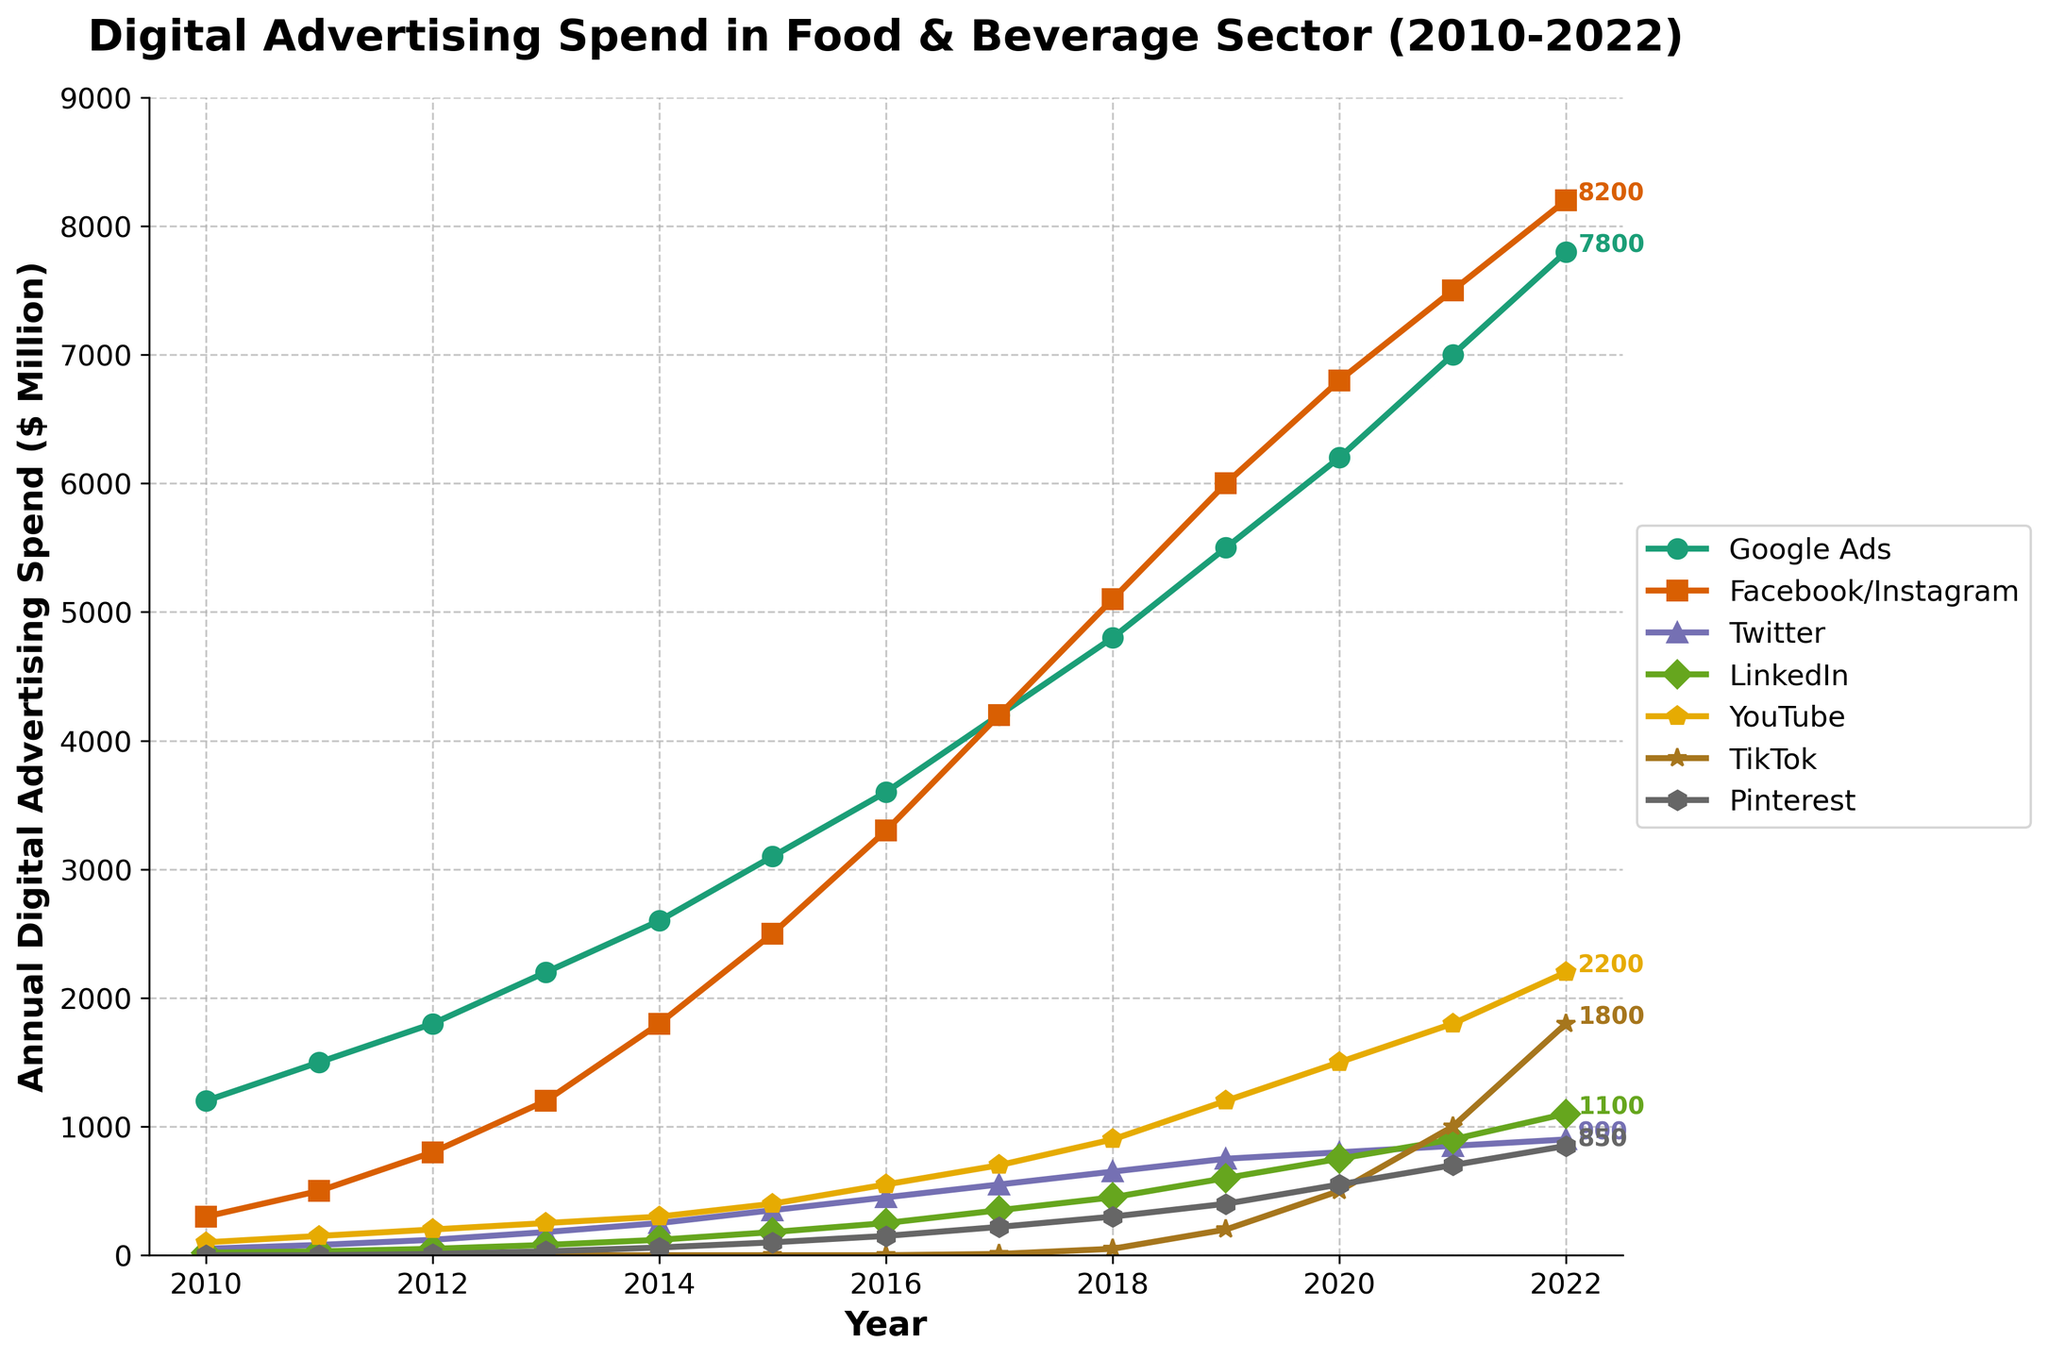what's the overall trend in Google Ads spending from 2010 to 2022? By observing the line representing Google Ads, we can see a steady increase in the annual advertising spend over the years. The line moves upwards from approximately $1200M in 2010 to around $7800M in 2022, indicating a consistent rise.
Answer: Increasing trend Which platform saw the largest growth in advertising spend between 2017 and 2022? To determine the largest growth, we need to compare the increase in spend for each platform between 2017 and 2022. By subtracting the 2017 values from the 2022 values, YouTube had the highest increase from $700M to $2200M, which is an increase of $1500M.
Answer: YouTube What's the difference in advertising spend between Google Ads and Facebook/Instagram in 2022? For 2022, the advertising spend for Google Ads is $7800M and for Facebook/Instagram is $8200M. The difference is calculated by subtracting Google Ads spend from Facebook/Instagram spend: $8200M - $7800M = $400M.
Answer: $400M Which platform had the smallest advertising spend in 2010? By looking at the values for all platforms in 2010, Twitter had the smallest spend with $50M, followed closely by LinkedIn with $20M.
Answer: LinkedIn How did TikTok's advertising spend evolve from its first recorded year to 2022? TikTok's advertising spend appeared for the first time in 2017 with $10M. Over the years, the spend increased steadily up to $1800M in 2022. This shows a significant upward trend in TikTok's advertising budget.
Answer: Significant increase What is the cumulative advertising spend for Pinterest across all years presented? To get the cumulative spend for Pinterest, sum up the values from 2012 to 2022: 10 + 30 + 60 + 100 + 150 + 220 + 300 + 400 + 550 + 700 + 850 = 3370M.
Answer: $3370M Between which consecutive years did LinkedIn see the highest growth rate in advertising spend? To determine the growth rate, we compare the annual differences. The difference between 2021 and 2022 is the highest with a jump from $900M to $1100M, an increase of $200M.
Answer: 2021-2022 In which year was the combined advertising spend on Google Ads and Facebook/Instagram first over $10,000M? Adding yearly spends for Google Ads and Facebook/Instagram for each year, the first instance where the sum surpasses $10,000M is in 2019 with $5500M (Google Ads) + $6000M (Facebook/Instagram) = $11500M.
Answer: 2019 Which platform shows the least variation in annual digital advertising spend over the period? By observing the line chart, LinkedIn shows relatively steady growth compared to larger fluctuations in other platforms like Facebook/Instagram and YouTube.
Answer: LinkedIn 